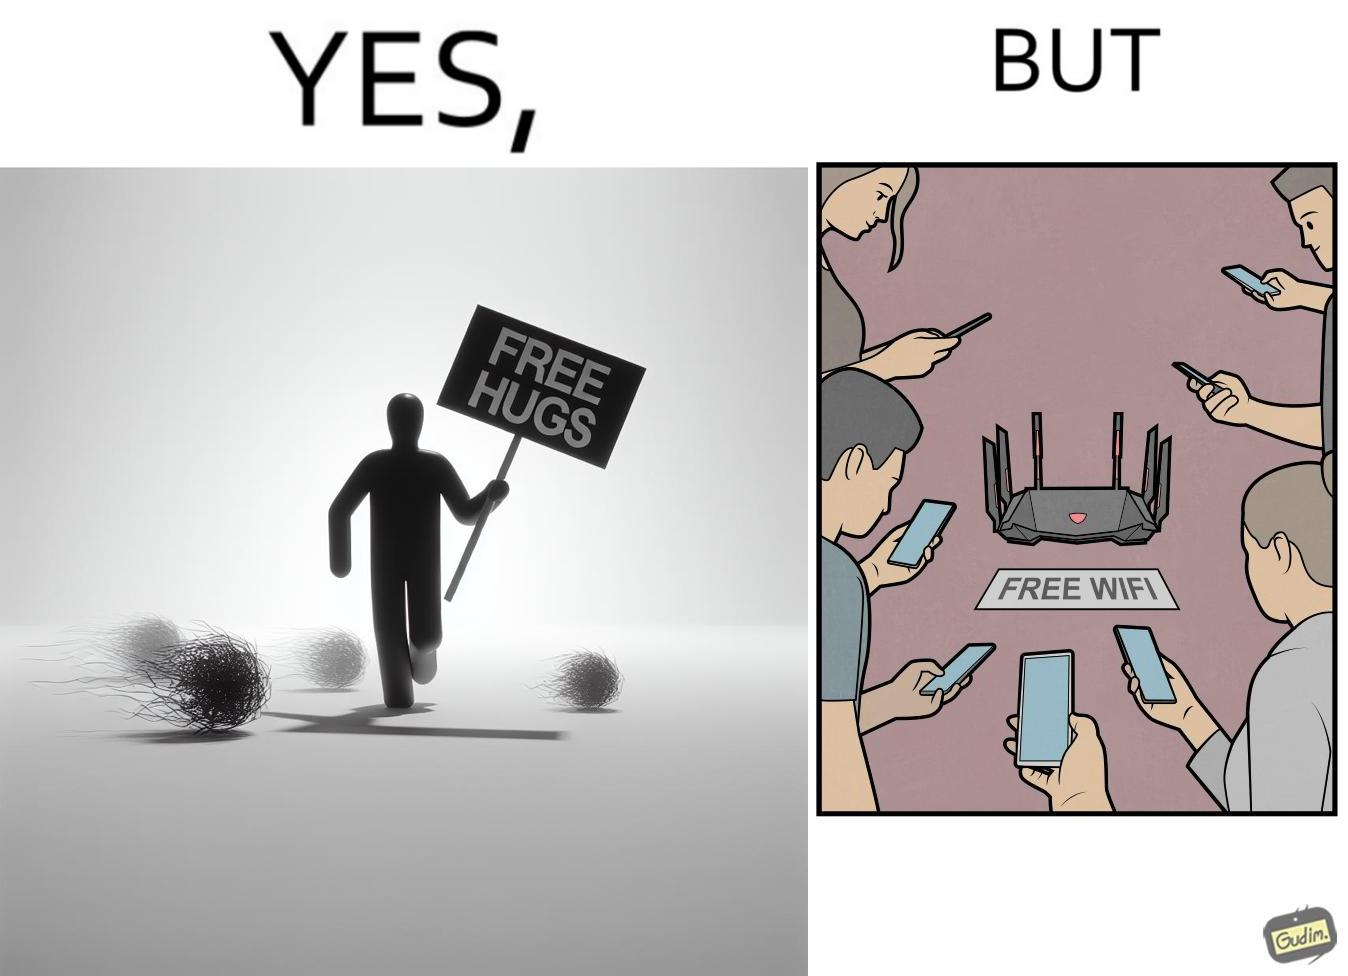Describe what you see in this image. This image is ironical, as a person holding up a "Free Hugs" sign is standing alone, while an inanimate Wi-fi Router giving "Free Wifi" is surrounded people trying to connect to it. This shows a growing lack of empathy in our society, while showing our increasing dependence on the digital devices in a virtual world. 